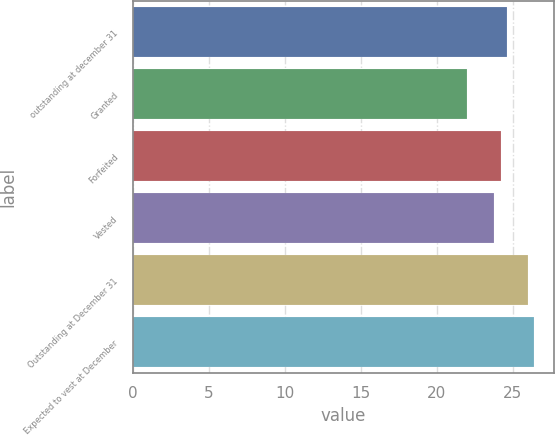Convert chart to OTSL. <chart><loc_0><loc_0><loc_500><loc_500><bar_chart><fcel>outstanding at december 31<fcel>Granted<fcel>Forfeited<fcel>Vested<fcel>Outstanding at December 31<fcel>Expected to vest at December<nl><fcel>24.6<fcel>22<fcel>24.2<fcel>23.8<fcel>26<fcel>26.4<nl></chart> 